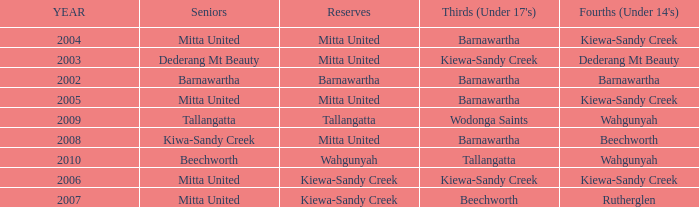Which seniors have a year before 2007, Fourths (Under 14's) of kiewa-sandy creek, and a Reserve of mitta united? Mitta United, Mitta United. 